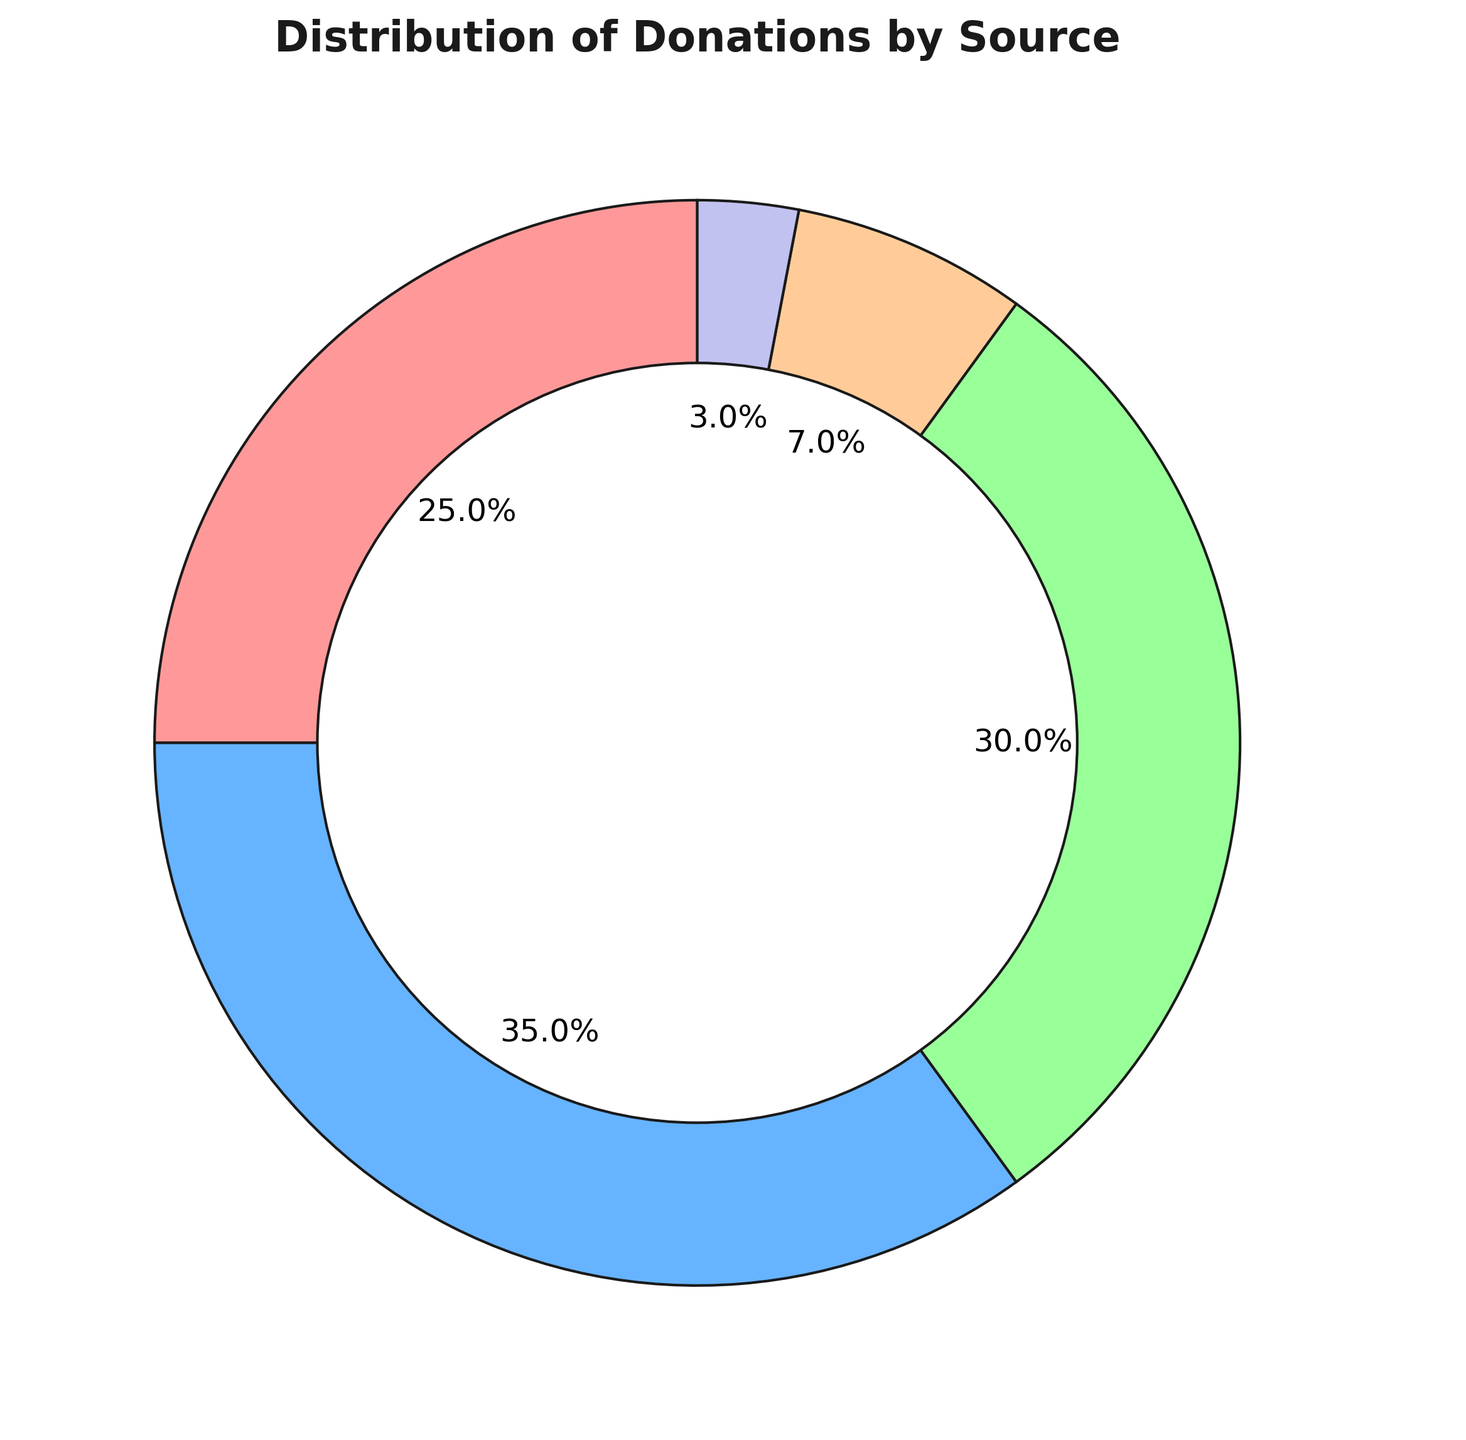Which donation source has the highest percentage? The pie chart shows the distribution of donations. By visually inspecting the chart, the largest slice corresponds to the Corporate source.
Answer: Corporate What's the combined percentage of donations from Crowdfunding and Individuals? According to the pie chart, Crowdfunding has a percentage of 25, and Individual donations have a percentage of 30. Adding these together gives 25 + 30 = 55.
Answer: 55 How much greater is the percentage of Corporate donations compared to Government Grants? From the chart, Corporate donations account for 35%, while Government Grants account for 7%. The difference is 35 - 7 = 28.
Answer: 28 Which donation sources have percentages less than 10%? From the pie chart, we can visually see that both Government Grants (7%) and Foundations (3%) have donation percentages less than 10%.
Answer: Government Grants and Foundations What is the second largest source of donations? By examining the pie chart, we see that the second largest slice belongs to Individual donations, which account for 30% of the total donations.
Answer: Individual What is the percentage difference between Crowdfunding and Foundations? The slice for Crowdfunding is 25%, and the slice for Foundations is 3%. The difference between these percentages is 25 - 3 = 22.
Answer: 22 If combining Foundations and Government Grants, what percentage of total donations does this represent? The pie chart shows that Foundations account for 3% and Government Grants account for 7%. Combined, they represent 3 + 7 = 10%.
Answer: 10 How does the donation percentage from Corporate compare to that from Individual donors? Visually inspecting the chart, Corporate donations have a percentage of 35, whereas Individual donations have 30%. Corporate has a greater percentage compared to Individual by 35 - 30 = 5%.
Answer: Corporate by 5 What color represents the Crowdfunding donation source? The Crowdfunding slice in the pie chart is represented by the red segment.
Answer: Red 